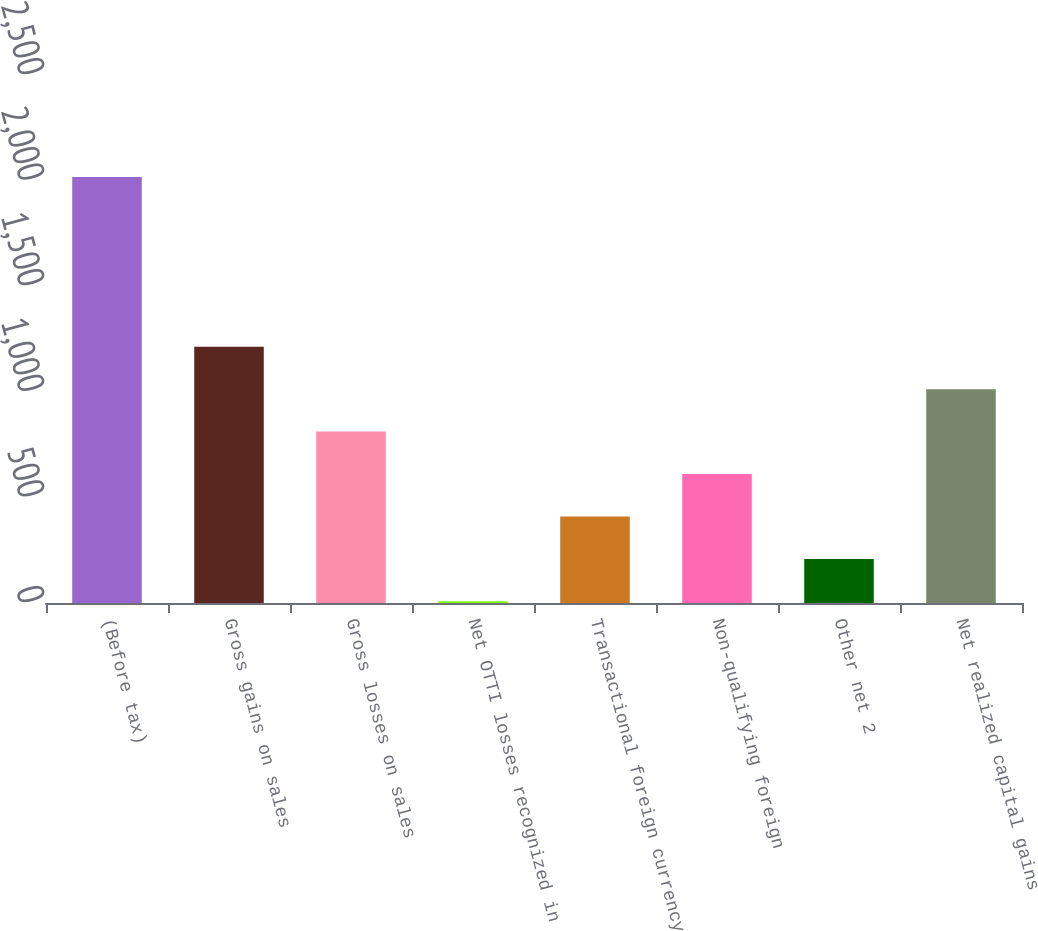<chart> <loc_0><loc_0><loc_500><loc_500><bar_chart><fcel>(Before tax)<fcel>Gross gains on sales<fcel>Gross losses on sales<fcel>Net OTTI losses recognized in<fcel>Transactional foreign currency<fcel>Non-qualifying foreign<fcel>Other net 2<fcel>Net realized capital gains<nl><fcel>2017<fcel>1213.4<fcel>811.6<fcel>8<fcel>409.8<fcel>610.7<fcel>208.9<fcel>1012.5<nl></chart> 